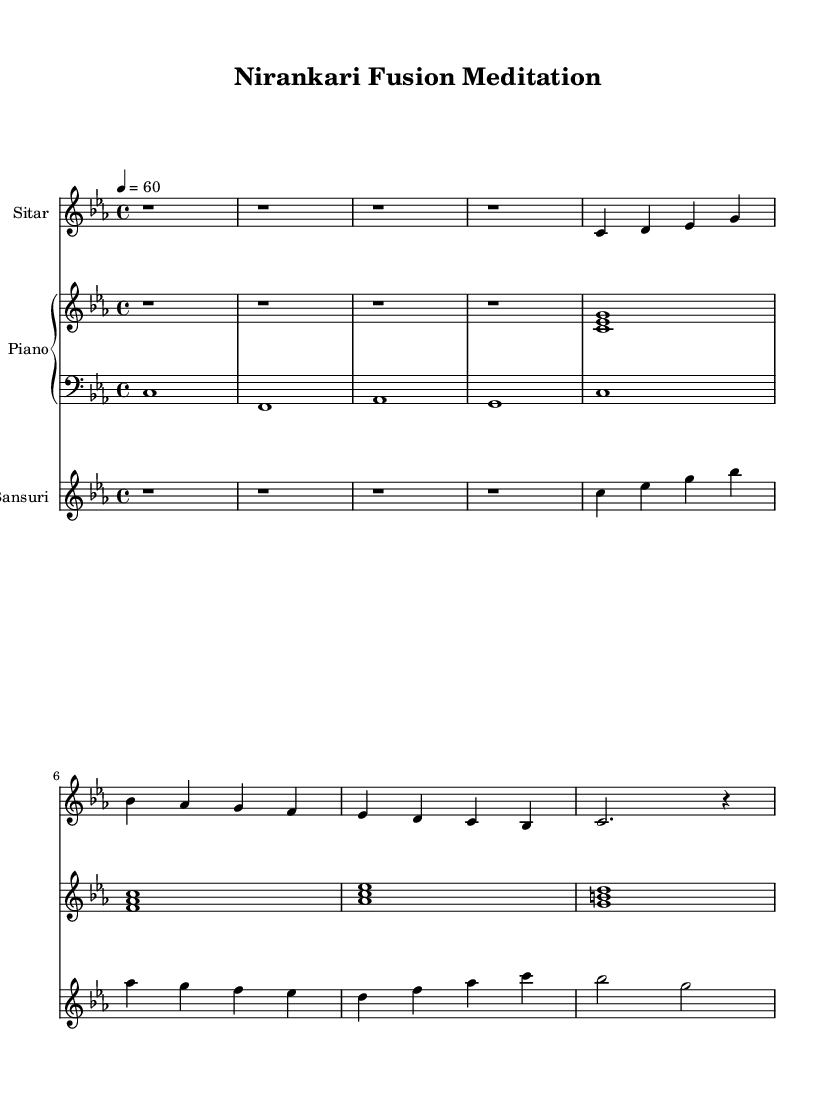What is the key signature of this music? The key signature is C minor, which includes three flats (B♭, E♭, A♭). This can be determined by looking at the key signature indicator at the beginning of the staff, which is C minor.
Answer: C minor What is the time signature of this piece? The time signature is 4/4, indicating four beats per measure and a quarter note receives one beat. This is noted at the beginning of the piece next to the key signature.
Answer: 4/4 What tempo marking is indicated for this music? The tempo marking indicates a speed of 60 beats per minute, as written as "4 = 60" underneath the tempo indication. This means there are 60 quarter note beats per minute.
Answer: 60 How many measures are in the sitar part? The sitar part consists of 8 measures, as evidenced by the presence of 8 distinct groups of notes or rests within the staff. Counting the individual measures shows there are a total of 8.
Answer: 8 Which instrument plays a melody starting on the note C? The bansuri starts its melody on the note C, as seen in the very first measure of the bansuri part, where the notes begin with C.
Answer: Bansuri What are the chords in the piano part's first measure? The first measure of the piano part contains the chords C minor (C, E♭, G), which can be identified by looking at the notes played simultaneously in that measure. This can be confirmed by identifying the notes that form the chord.
Answer: C minor What is the last note played in the bass part? The last note in the bass part is C, as indicated by the final note in the last measure of the bass staff, which shows a whole note C played.
Answer: C 